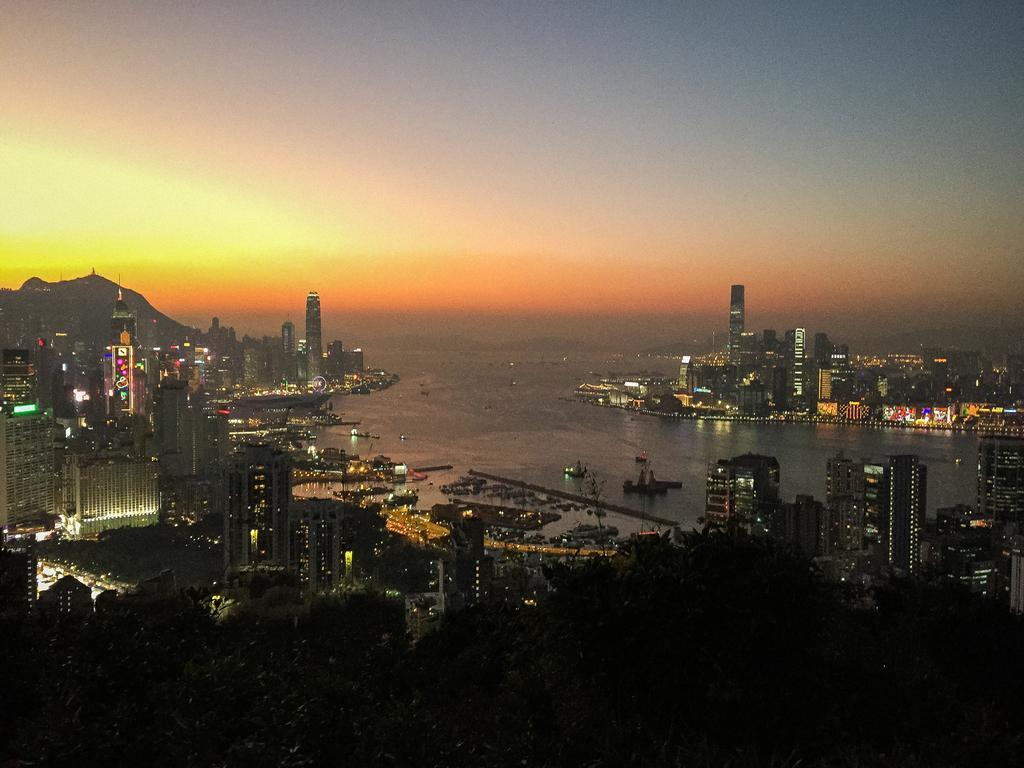How would you summarize this image in a sentence or two? This is the picture of a city. In this image there are buildings, trees and poles and there are boats on the water. At the back there is a mountain. At the top there is sky. At the bottom there is water. 